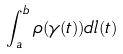<formula> <loc_0><loc_0><loc_500><loc_500>\int _ { a } ^ { b } \rho ( \gamma ( t ) ) d l ( t )</formula> 